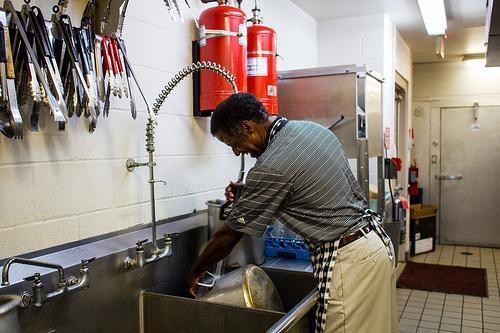How many fire extinguisher canisters are on the wall?
Give a very brief answer. 2. How many men in the photograph?
Give a very brief answer. 1. How many people are in the photo?
Give a very brief answer. 1. 